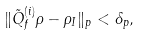<formula> <loc_0><loc_0><loc_500><loc_500>\| \tilde { Q } _ { f } ^ { \left ( i \right ) } \rho - \rho _ { I } \| _ { p } < \delta _ { p } ,</formula> 